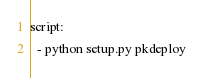<code> <loc_0><loc_0><loc_500><loc_500><_YAML_>script:
  - python setup.py pkdeploy
</code> 